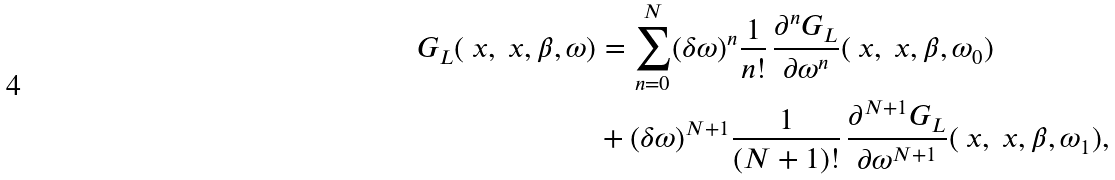<formula> <loc_0><loc_0><loc_500><loc_500>G _ { L } ( \ x , \ x , \beta , \omega ) & = \sum _ { n = 0 } ^ { N } ( \delta \omega ) ^ { n } \frac { 1 } { n ! } \, \frac { \partial ^ { n } G _ { L } } { \partial \omega ^ { n } } ( \ x , \ x , \beta , \omega _ { 0 } ) \\ & + ( \delta \omega ) ^ { N + 1 } \frac { 1 } { ( N + 1 ) ! } \, \frac { \partial ^ { N + 1 } G _ { L } } { \partial \omega ^ { N + 1 } } ( \ x , \ x , \beta , \omega _ { 1 } ) ,</formula> 